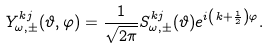Convert formula to latex. <formula><loc_0><loc_0><loc_500><loc_500>Y _ { \omega , \pm } ^ { k j } ( \vartheta , \varphi ) = \frac { 1 } { \sqrt { 2 \pi } } S _ { \omega , \pm } ^ { k j } ( \vartheta ) e ^ { i \left ( k + \frac { 1 } { 2 } \right ) \varphi } .</formula> 